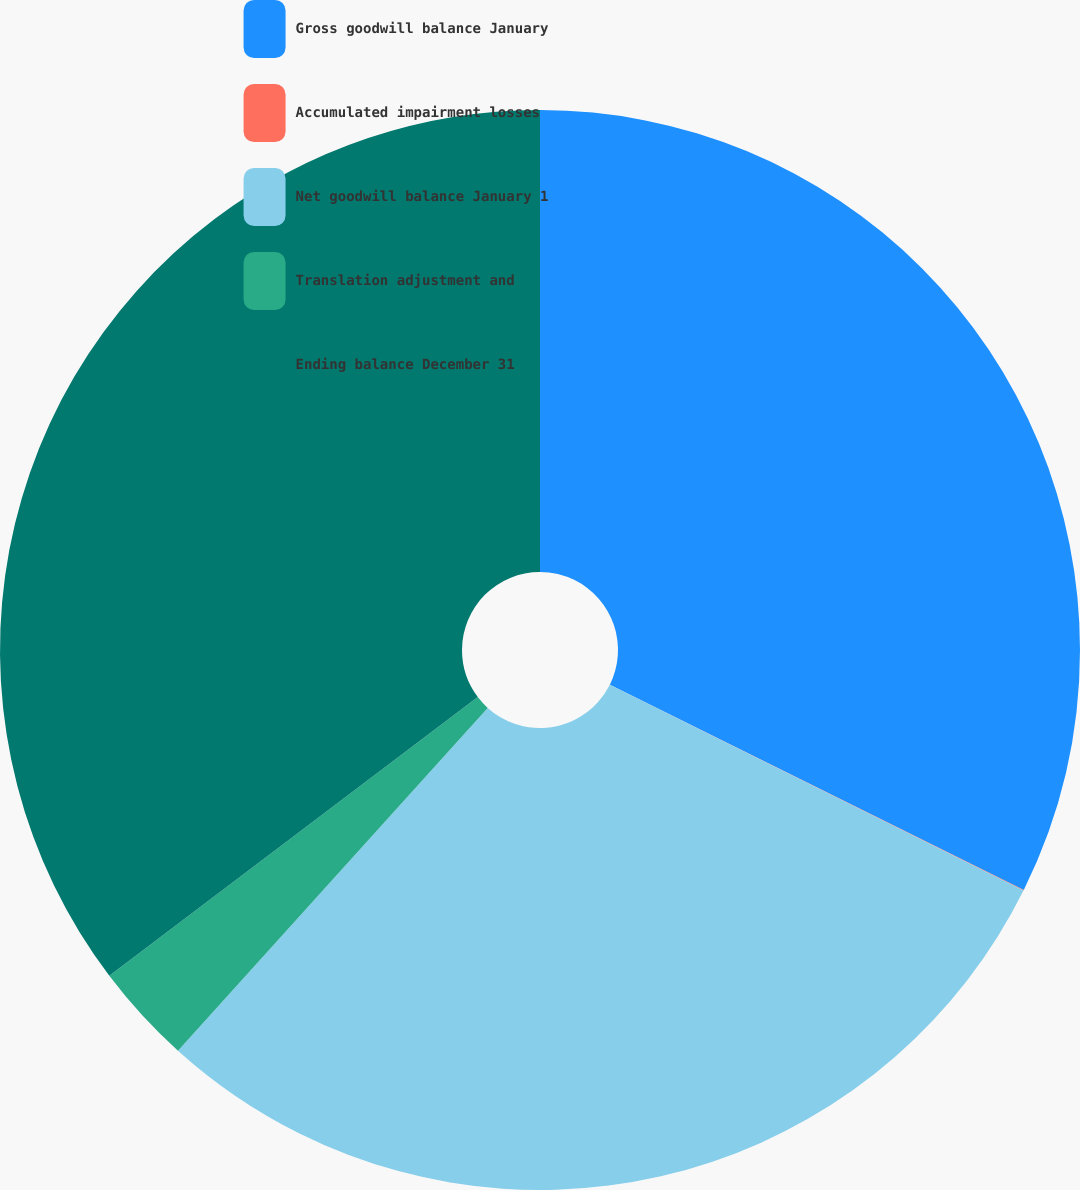Convert chart to OTSL. <chart><loc_0><loc_0><loc_500><loc_500><pie_chart><fcel>Gross goodwill balance January<fcel>Accumulated impairment losses<fcel>Net goodwill balance January 1<fcel>Translation adjustment and<fcel>Ending balance December 31<nl><fcel>32.33%<fcel>0.02%<fcel>29.35%<fcel>3.0%<fcel>35.31%<nl></chart> 